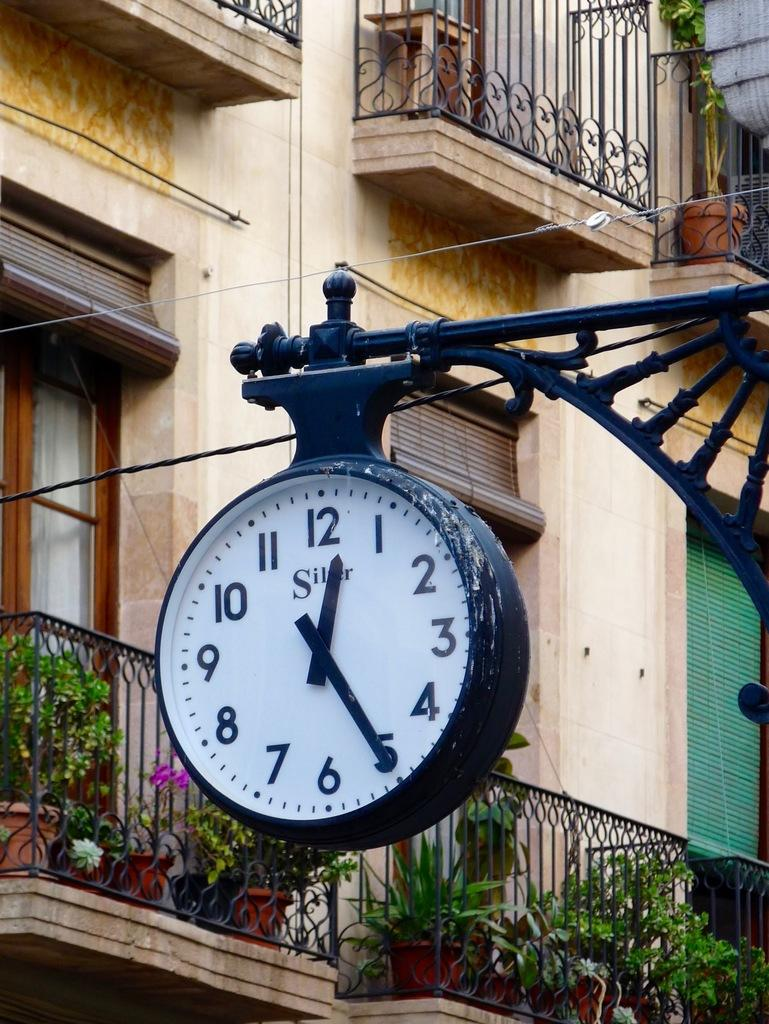<image>
Write a terse but informative summary of the picture. A clock which is set to twenty five minutes past twelve. 